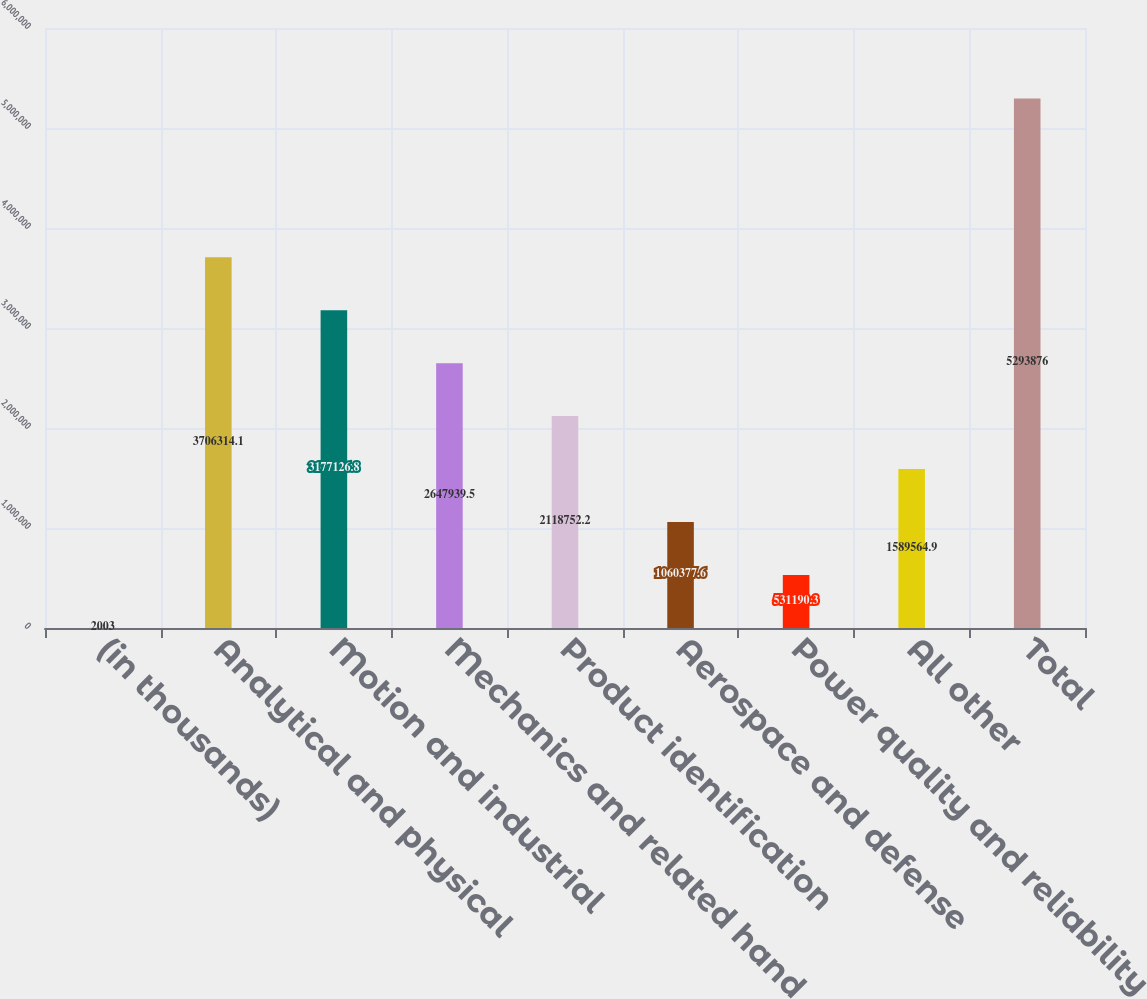Convert chart to OTSL. <chart><loc_0><loc_0><loc_500><loc_500><bar_chart><fcel>(in thousands)<fcel>Analytical and physical<fcel>Motion and industrial<fcel>Mechanics and related hand<fcel>Product identification<fcel>Aerospace and defense<fcel>Power quality and reliability<fcel>All other<fcel>Total<nl><fcel>2003<fcel>3.70631e+06<fcel>3.17713e+06<fcel>2.64794e+06<fcel>2.11875e+06<fcel>1.06038e+06<fcel>531190<fcel>1.58956e+06<fcel>5.29388e+06<nl></chart> 